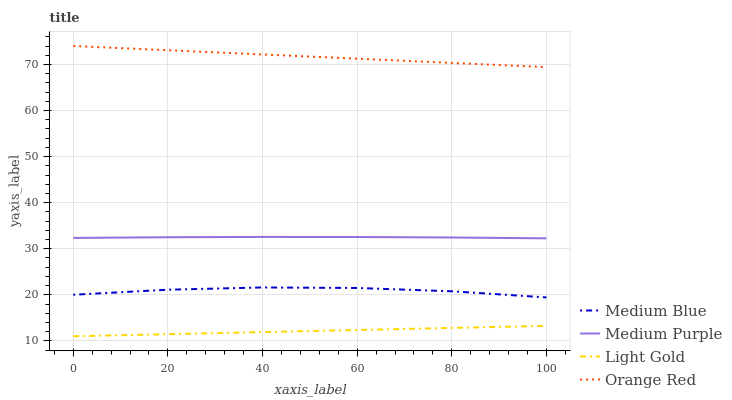Does Light Gold have the minimum area under the curve?
Answer yes or no. Yes. Does Orange Red have the maximum area under the curve?
Answer yes or no. Yes. Does Medium Blue have the minimum area under the curve?
Answer yes or no. No. Does Medium Blue have the maximum area under the curve?
Answer yes or no. No. Is Light Gold the smoothest?
Answer yes or no. Yes. Is Medium Blue the roughest?
Answer yes or no. Yes. Is Medium Blue the smoothest?
Answer yes or no. No. Is Light Gold the roughest?
Answer yes or no. No. Does Medium Blue have the lowest value?
Answer yes or no. No. Does Orange Red have the highest value?
Answer yes or no. Yes. Does Medium Blue have the highest value?
Answer yes or no. No. Is Light Gold less than Orange Red?
Answer yes or no. Yes. Is Medium Purple greater than Light Gold?
Answer yes or no. Yes. Does Light Gold intersect Orange Red?
Answer yes or no. No. 